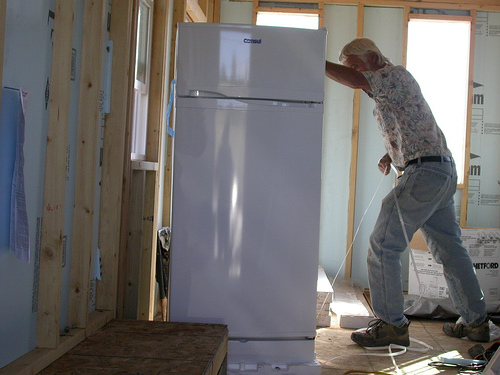Please transcribe the text information in this image. m m MITK 